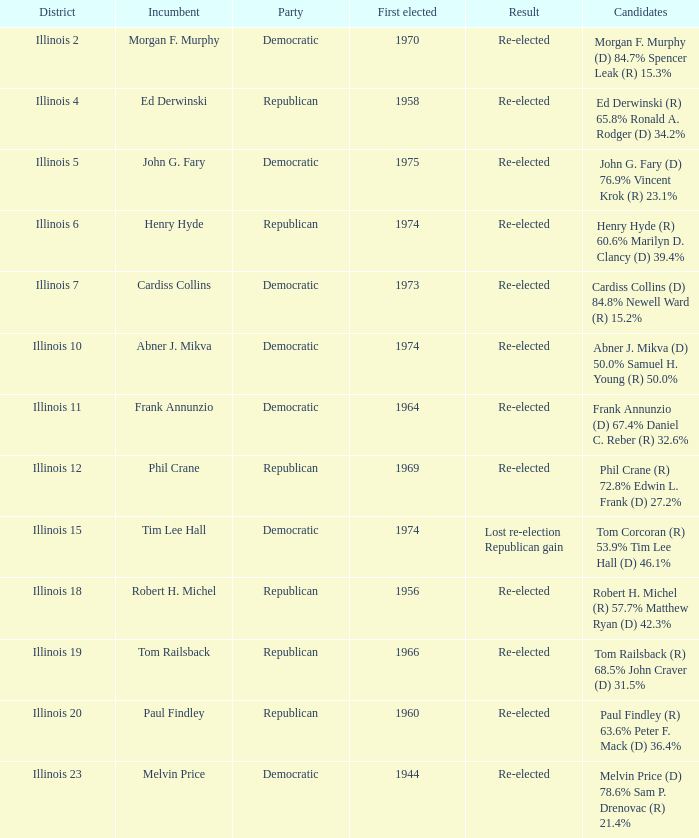Name the district for tim lee hall Illinois 15. 